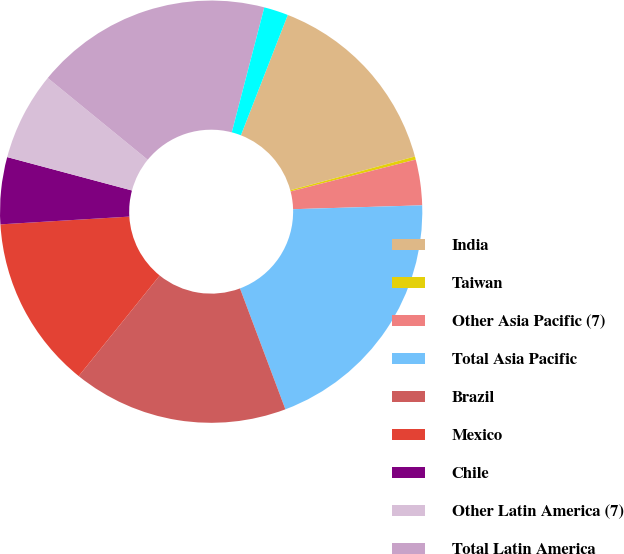<chart> <loc_0><loc_0><loc_500><loc_500><pie_chart><fcel>India<fcel>Taiwan<fcel>Other Asia Pacific (7)<fcel>Total Asia Pacific<fcel>Brazil<fcel>Mexico<fcel>Chile<fcel>Other Latin America (7)<fcel>Total Latin America<fcel>Other Middle East and Africa<nl><fcel>14.88%<fcel>0.24%<fcel>3.49%<fcel>19.76%<fcel>16.51%<fcel>13.25%<fcel>5.12%<fcel>6.75%<fcel>18.14%<fcel>1.86%<nl></chart> 